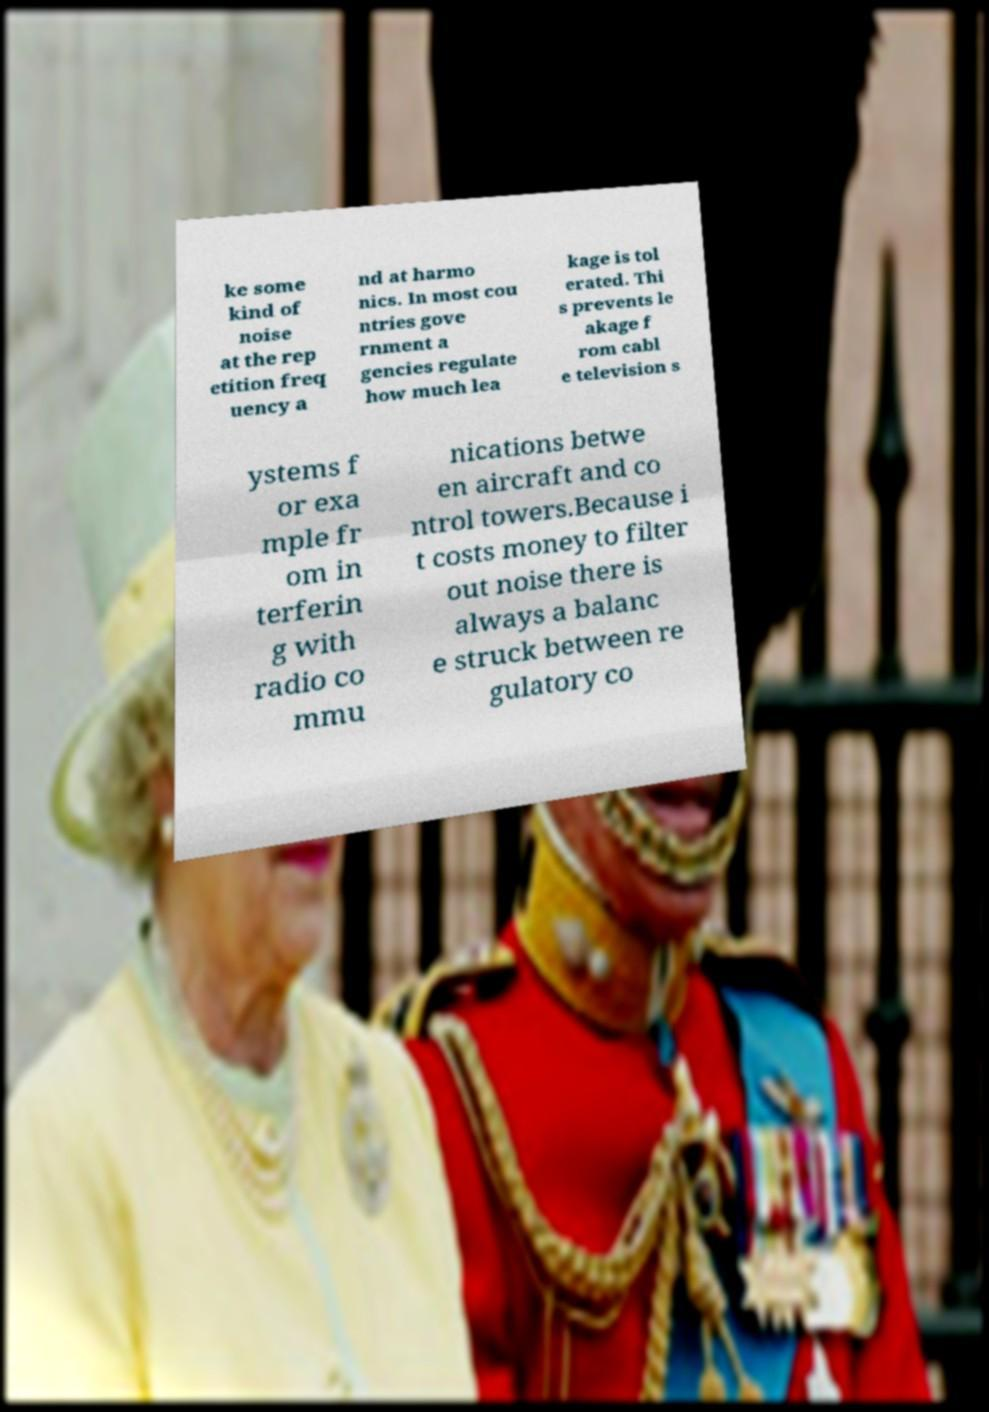For documentation purposes, I need the text within this image transcribed. Could you provide that? ke some kind of noise at the rep etition freq uency a nd at harmo nics. In most cou ntries gove rnment a gencies regulate how much lea kage is tol erated. Thi s prevents le akage f rom cabl e television s ystems f or exa mple fr om in terferin g with radio co mmu nications betwe en aircraft and co ntrol towers.Because i t costs money to filter out noise there is always a balanc e struck between re gulatory co 